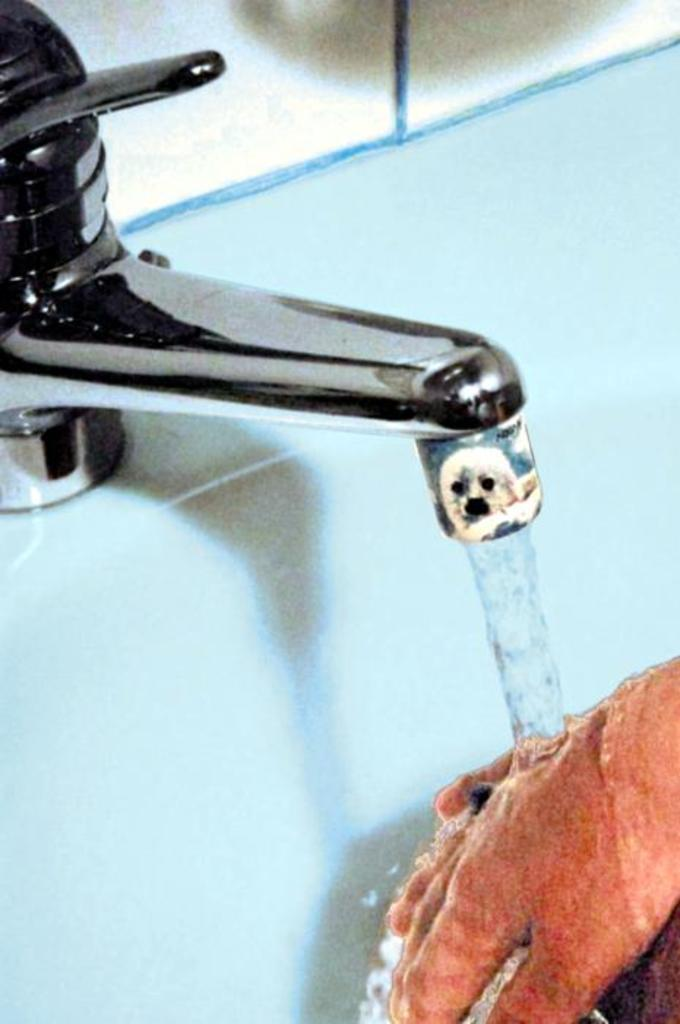What is the person in the image doing? The person is washing their hands in the image. Where is the person washing their hands? The person is doing this under a tap in the image. What is the person using to wash their hands? There is a wash basin in the image, which the person is using. What is the source of water for washing hands? There is a tap in the image, which is providing the water. What can be seen in the background of the image? In the background, there might be a mirror or a white wall. How many roses are on the person's head in the image? There are no roses present on the person's head in the image. What type of test is the person taking in the image? There is no test being taken in the image; the person is simply washing their hands. 